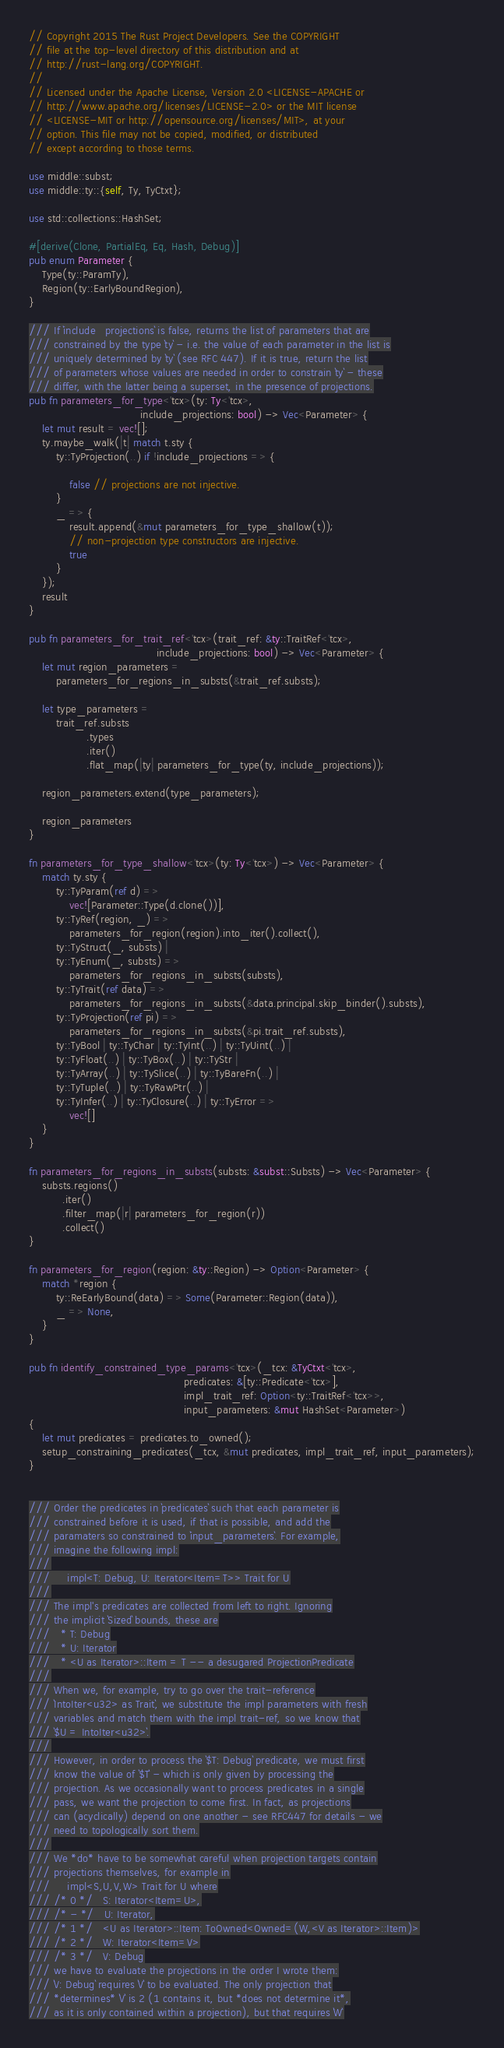<code> <loc_0><loc_0><loc_500><loc_500><_Rust_>// Copyright 2015 The Rust Project Developers. See the COPYRIGHT
// file at the top-level directory of this distribution and at
// http://rust-lang.org/COPYRIGHT.
//
// Licensed under the Apache License, Version 2.0 <LICENSE-APACHE or
// http://www.apache.org/licenses/LICENSE-2.0> or the MIT license
// <LICENSE-MIT or http://opensource.org/licenses/MIT>, at your
// option. This file may not be copied, modified, or distributed
// except according to those terms.

use middle::subst;
use middle::ty::{self, Ty, TyCtxt};

use std::collections::HashSet;

#[derive(Clone, PartialEq, Eq, Hash, Debug)]
pub enum Parameter {
    Type(ty::ParamTy),
    Region(ty::EarlyBoundRegion),
}

/// If `include_projections` is false, returns the list of parameters that are
/// constrained by the type `ty` - i.e. the value of each parameter in the list is
/// uniquely determined by `ty` (see RFC 447). If it is true, return the list
/// of parameters whose values are needed in order to constrain `ty` - these
/// differ, with the latter being a superset, in the presence of projections.
pub fn parameters_for_type<'tcx>(ty: Ty<'tcx>,
                                 include_projections: bool) -> Vec<Parameter> {
    let mut result = vec![];
    ty.maybe_walk(|t| match t.sty {
        ty::TyProjection(..) if !include_projections => {

            false // projections are not injective.
        }
        _ => {
            result.append(&mut parameters_for_type_shallow(t));
            // non-projection type constructors are injective.
            true
        }
    });
    result
}

pub fn parameters_for_trait_ref<'tcx>(trait_ref: &ty::TraitRef<'tcx>,
                                      include_projections: bool) -> Vec<Parameter> {
    let mut region_parameters =
        parameters_for_regions_in_substs(&trait_ref.substs);

    let type_parameters =
        trait_ref.substs
                 .types
                 .iter()
                 .flat_map(|ty| parameters_for_type(ty, include_projections));

    region_parameters.extend(type_parameters);

    region_parameters
}

fn parameters_for_type_shallow<'tcx>(ty: Ty<'tcx>) -> Vec<Parameter> {
    match ty.sty {
        ty::TyParam(ref d) =>
            vec![Parameter::Type(d.clone())],
        ty::TyRef(region, _) =>
            parameters_for_region(region).into_iter().collect(),
        ty::TyStruct(_, substs) |
        ty::TyEnum(_, substs) =>
            parameters_for_regions_in_substs(substs),
        ty::TyTrait(ref data) =>
            parameters_for_regions_in_substs(&data.principal.skip_binder().substs),
        ty::TyProjection(ref pi) =>
            parameters_for_regions_in_substs(&pi.trait_ref.substs),
        ty::TyBool | ty::TyChar | ty::TyInt(..) | ty::TyUint(..) |
        ty::TyFloat(..) | ty::TyBox(..) | ty::TyStr |
        ty::TyArray(..) | ty::TySlice(..) | ty::TyBareFn(..) |
        ty::TyTuple(..) | ty::TyRawPtr(..) |
        ty::TyInfer(..) | ty::TyClosure(..) | ty::TyError =>
            vec![]
    }
}

fn parameters_for_regions_in_substs(substs: &subst::Substs) -> Vec<Parameter> {
    substs.regions()
          .iter()
          .filter_map(|r| parameters_for_region(r))
          .collect()
}

fn parameters_for_region(region: &ty::Region) -> Option<Parameter> {
    match *region {
        ty::ReEarlyBound(data) => Some(Parameter::Region(data)),
        _ => None,
    }
}

pub fn identify_constrained_type_params<'tcx>(_tcx: &TyCtxt<'tcx>,
                                              predicates: &[ty::Predicate<'tcx>],
                                              impl_trait_ref: Option<ty::TraitRef<'tcx>>,
                                              input_parameters: &mut HashSet<Parameter>)
{
    let mut predicates = predicates.to_owned();
    setup_constraining_predicates(_tcx, &mut predicates, impl_trait_ref, input_parameters);
}


/// Order the predicates in `predicates` such that each parameter is
/// constrained before it is used, if that is possible, and add the
/// paramaters so constrained to `input_parameters`. For example,
/// imagine the following impl:
///
///     impl<T: Debug, U: Iterator<Item=T>> Trait for U
///
/// The impl's predicates are collected from left to right. Ignoring
/// the implicit `Sized` bounds, these are
///   * T: Debug
///   * U: Iterator
///   * <U as Iterator>::Item = T -- a desugared ProjectionPredicate
///
/// When we, for example, try to go over the trait-reference
/// `IntoIter<u32> as Trait`, we substitute the impl parameters with fresh
/// variables and match them with the impl trait-ref, so we know that
/// `$U = IntoIter<u32>`.
///
/// However, in order to process the `$T: Debug` predicate, we must first
/// know the value of `$T` - which is only given by processing the
/// projection. As we occasionally want to process predicates in a single
/// pass, we want the projection to come first. In fact, as projections
/// can (acyclically) depend on one another - see RFC447 for details - we
/// need to topologically sort them.
///
/// We *do* have to be somewhat careful when projection targets contain
/// projections themselves, for example in
///     impl<S,U,V,W> Trait for U where
/// /* 0 */   S: Iterator<Item=U>,
/// /* - */   U: Iterator,
/// /* 1 */   <U as Iterator>::Item: ToOwned<Owned=(W,<V as Iterator>::Item)>
/// /* 2 */   W: Iterator<Item=V>
/// /* 3 */   V: Debug
/// we have to evaluate the projections in the order I wrote them:
/// `V: Debug` requires `V` to be evaluated. The only projection that
/// *determines* `V` is 2 (1 contains it, but *does not determine it*,
/// as it is only contained within a projection), but that requires `W`</code> 